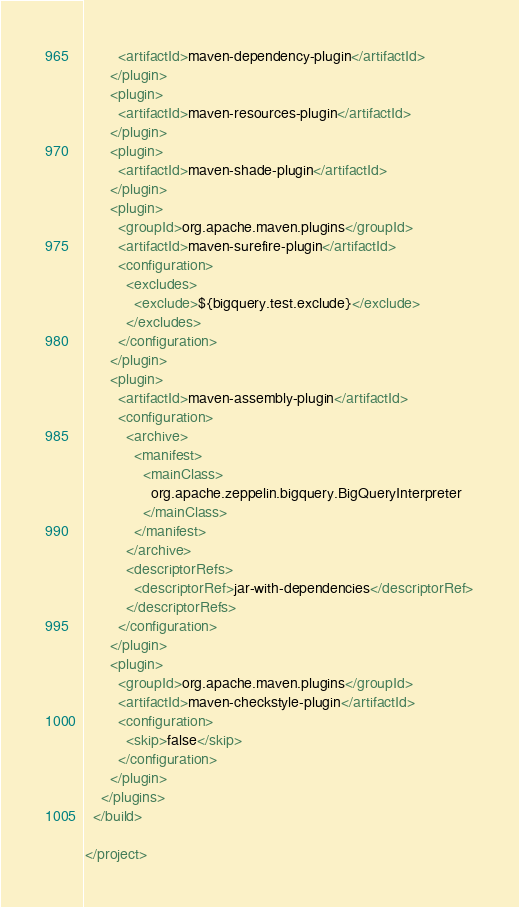Convert code to text. <code><loc_0><loc_0><loc_500><loc_500><_XML_>        <artifactId>maven-dependency-plugin</artifactId>
      </plugin>
      <plugin>
        <artifactId>maven-resources-plugin</artifactId>
      </plugin>
      <plugin>
        <artifactId>maven-shade-plugin</artifactId>
      </plugin>
      <plugin>
        <groupId>org.apache.maven.plugins</groupId>
        <artifactId>maven-surefire-plugin</artifactId>
        <configuration>
          <excludes>
            <exclude>${bigquery.test.exclude}</exclude>
          </excludes>
        </configuration>
      </plugin>
      <plugin>
        <artifactId>maven-assembly-plugin</artifactId>
        <configuration>
          <archive>
            <manifest>
              <mainClass>
                org.apache.zeppelin.bigquery.BigQueryInterpreter
              </mainClass>
            </manifest>
          </archive>
          <descriptorRefs>
            <descriptorRef>jar-with-dependencies</descriptorRef>
          </descriptorRefs>
        </configuration>
      </plugin>
      <plugin>
        <groupId>org.apache.maven.plugins</groupId>
        <artifactId>maven-checkstyle-plugin</artifactId>
        <configuration>
          <skip>false</skip>
        </configuration>
      </plugin>
    </plugins>
  </build>

</project>
</code> 